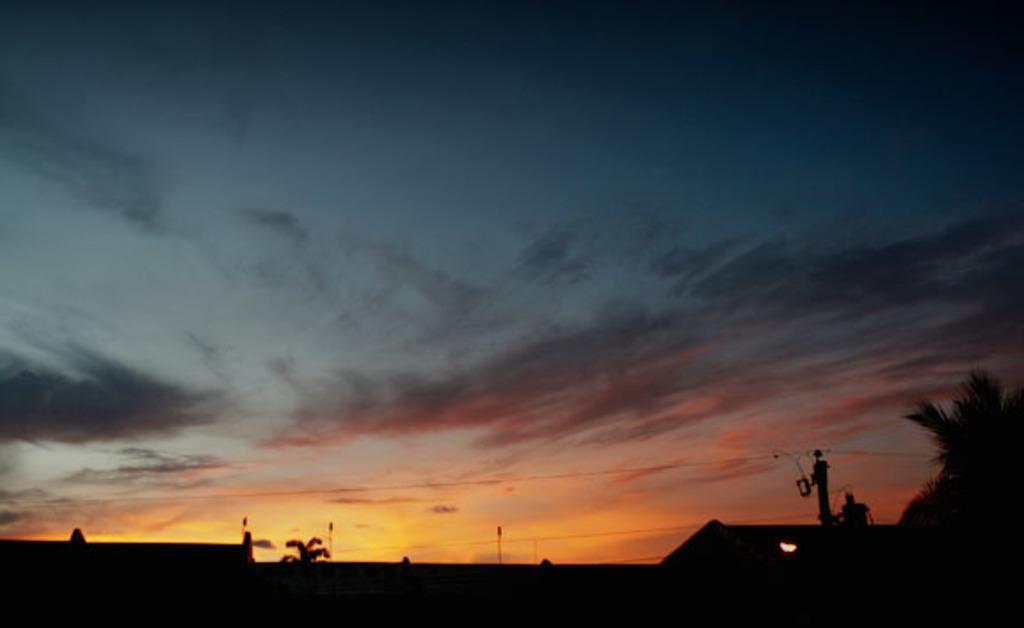Can you describe this image briefly? In the picture we can see the part of the house and beside it we can see a pole and a part of the coconut tree in the dark and behind it we can see the sky with clouds. 